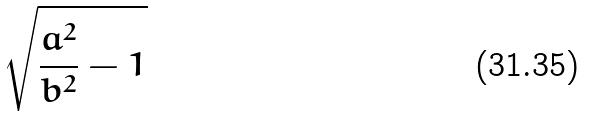<formula> <loc_0><loc_0><loc_500><loc_500>\sqrt { \frac { a ^ { 2 } } { b ^ { 2 } } - 1 }</formula> 